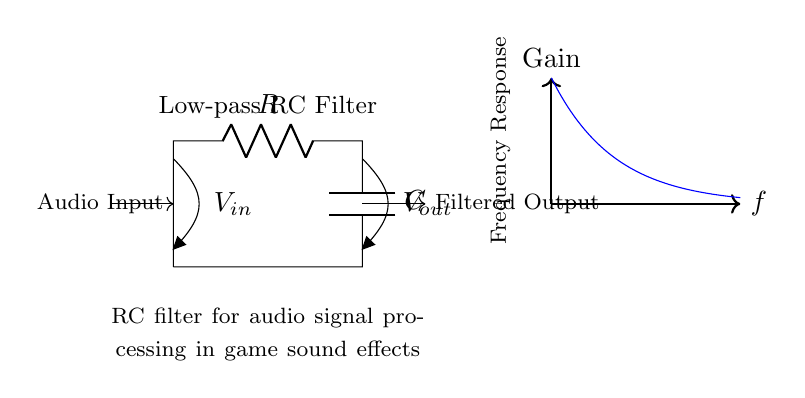What type of filter is represented in this circuit? This circuit comprises a resistor and capacitor in a configuration that allows low-frequency signals to pass while attenuating higher frequencies, characteristic of a low-pass filter.
Answer: Low-pass filter What are the input and output voltages labeled as? The input voltage is marked as V-in at the left side, while the output voltage is labeled V-out at the right side of the diagram.
Answer: V-in and V-out What is the purpose of this RC filter in audio signal processing? The RC filter is specifically designed to modify audio signals by reducing the amplitude of higher frequencies, ensuring a smoother sound for game effects.
Answer: To filter audio signals How does increasing the resistance affect the cutoff frequency of the filter? Increasing the resistance will lower the cutoff frequency of the low-pass filter, since the cutoff frequency is inversely proportional to resistance in an RC filter.
Answer: Lowers the cutoff frequency What happens to the gain at high frequencies in this circuit? At high frequencies, the gain approaches zero, indicating that the circuit significantly attenuates signals above the cutoff frequency.
Answer: Approaches zero Which components are used in this filter circuit? The components in this circuit are a resistor and a capacitor, which work together to create the filtering effect.
Answer: Resistor and capacitor What does the frequency response graph indicate about this circuit? The frequency response graph shows exponential decay of gain as frequency increases, highlighting that higher frequencies are attenuated more than lower frequencies.
Answer: Exponential decay of gain 